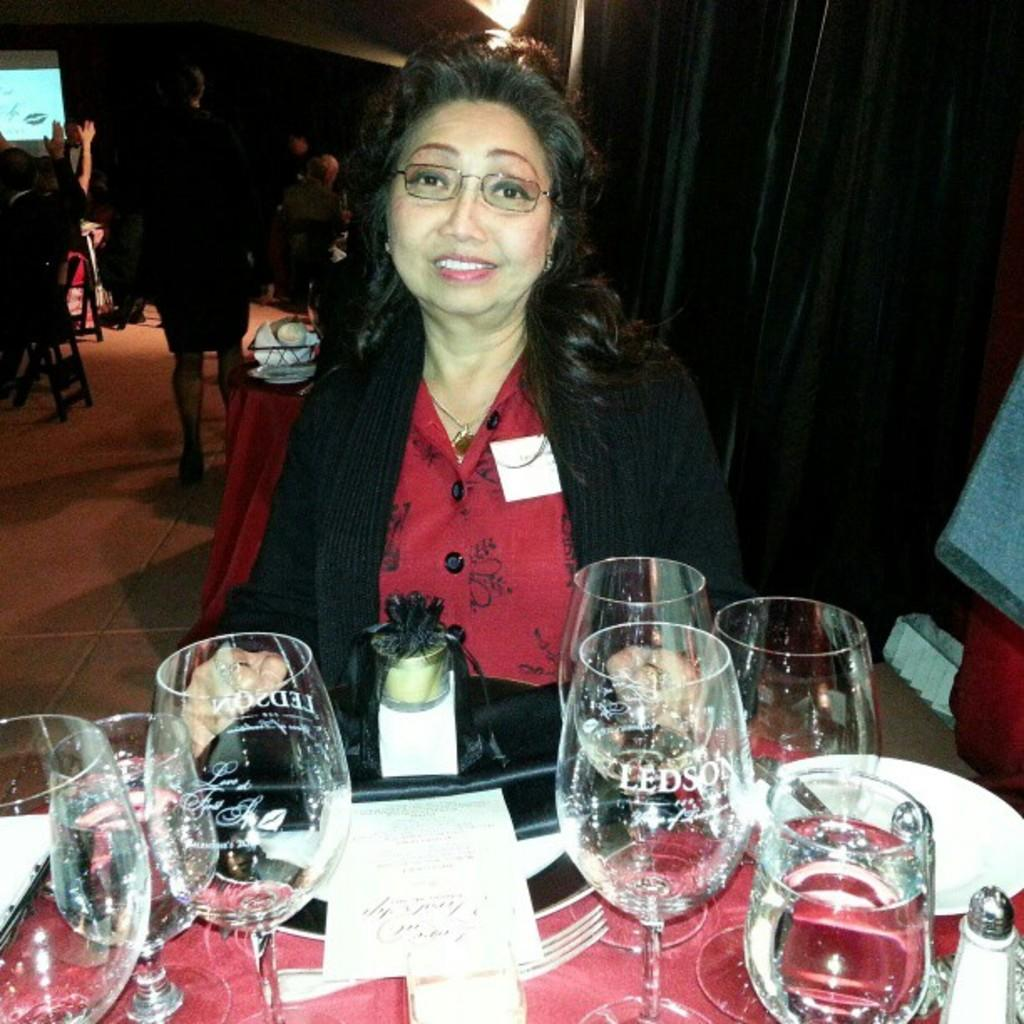What is the woman in the image doing? The woman is sitting on a chair in the image. What is in front of the woman? The woman is in front of a table. What can be seen on the table? There are numerous glasses on the table. Are there any other people in the image besides the woman? Yes, there is a group of people standing behind the woman. What force is being applied to the woman to stop her from standing up? There is no force being applied to the woman in the image, and she is not attempting to stand up. 